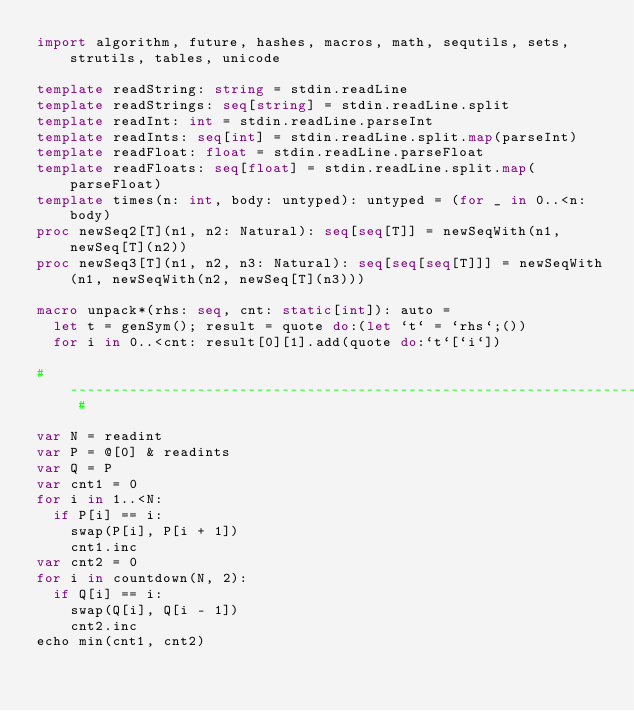<code> <loc_0><loc_0><loc_500><loc_500><_Nim_>import algorithm, future, hashes, macros, math, sequtils, sets, strutils, tables, unicode

template readString: string = stdin.readLine
template readStrings: seq[string] = stdin.readLine.split
template readInt: int = stdin.readLine.parseInt
template readInts: seq[int] = stdin.readLine.split.map(parseInt)
template readFloat: float = stdin.readLine.parseFloat
template readFloats: seq[float] = stdin.readLine.split.map(parseFloat)
template times(n: int, body: untyped): untyped = (for _ in 0..<n: body)
proc newSeq2[T](n1, n2: Natural): seq[seq[T]] = newSeqWith(n1, newSeq[T](n2))
proc newSeq3[T](n1, n2, n3: Natural): seq[seq[seq[T]]] = newSeqWith(n1, newSeqWith(n2, newSeq[T](n3)))

macro unpack*(rhs: seq, cnt: static[int]): auto =
  let t = genSym(); result = quote do:(let `t` = `rhs`;())
  for i in 0..<cnt: result[0][1].add(quote do:`t`[`i`])

# ------------------------------------------------------------------------------------------------------ #

var N = readint
var P = @[0] & readints
var Q = P
var cnt1 = 0
for i in 1..<N:
  if P[i] == i:
    swap(P[i], P[i + 1])
    cnt1.inc
var cnt2 = 0
for i in countdown(N, 2):
  if Q[i] == i:
    swap(Q[i], Q[i - 1])
    cnt2.inc
echo min(cnt1, cnt2)</code> 